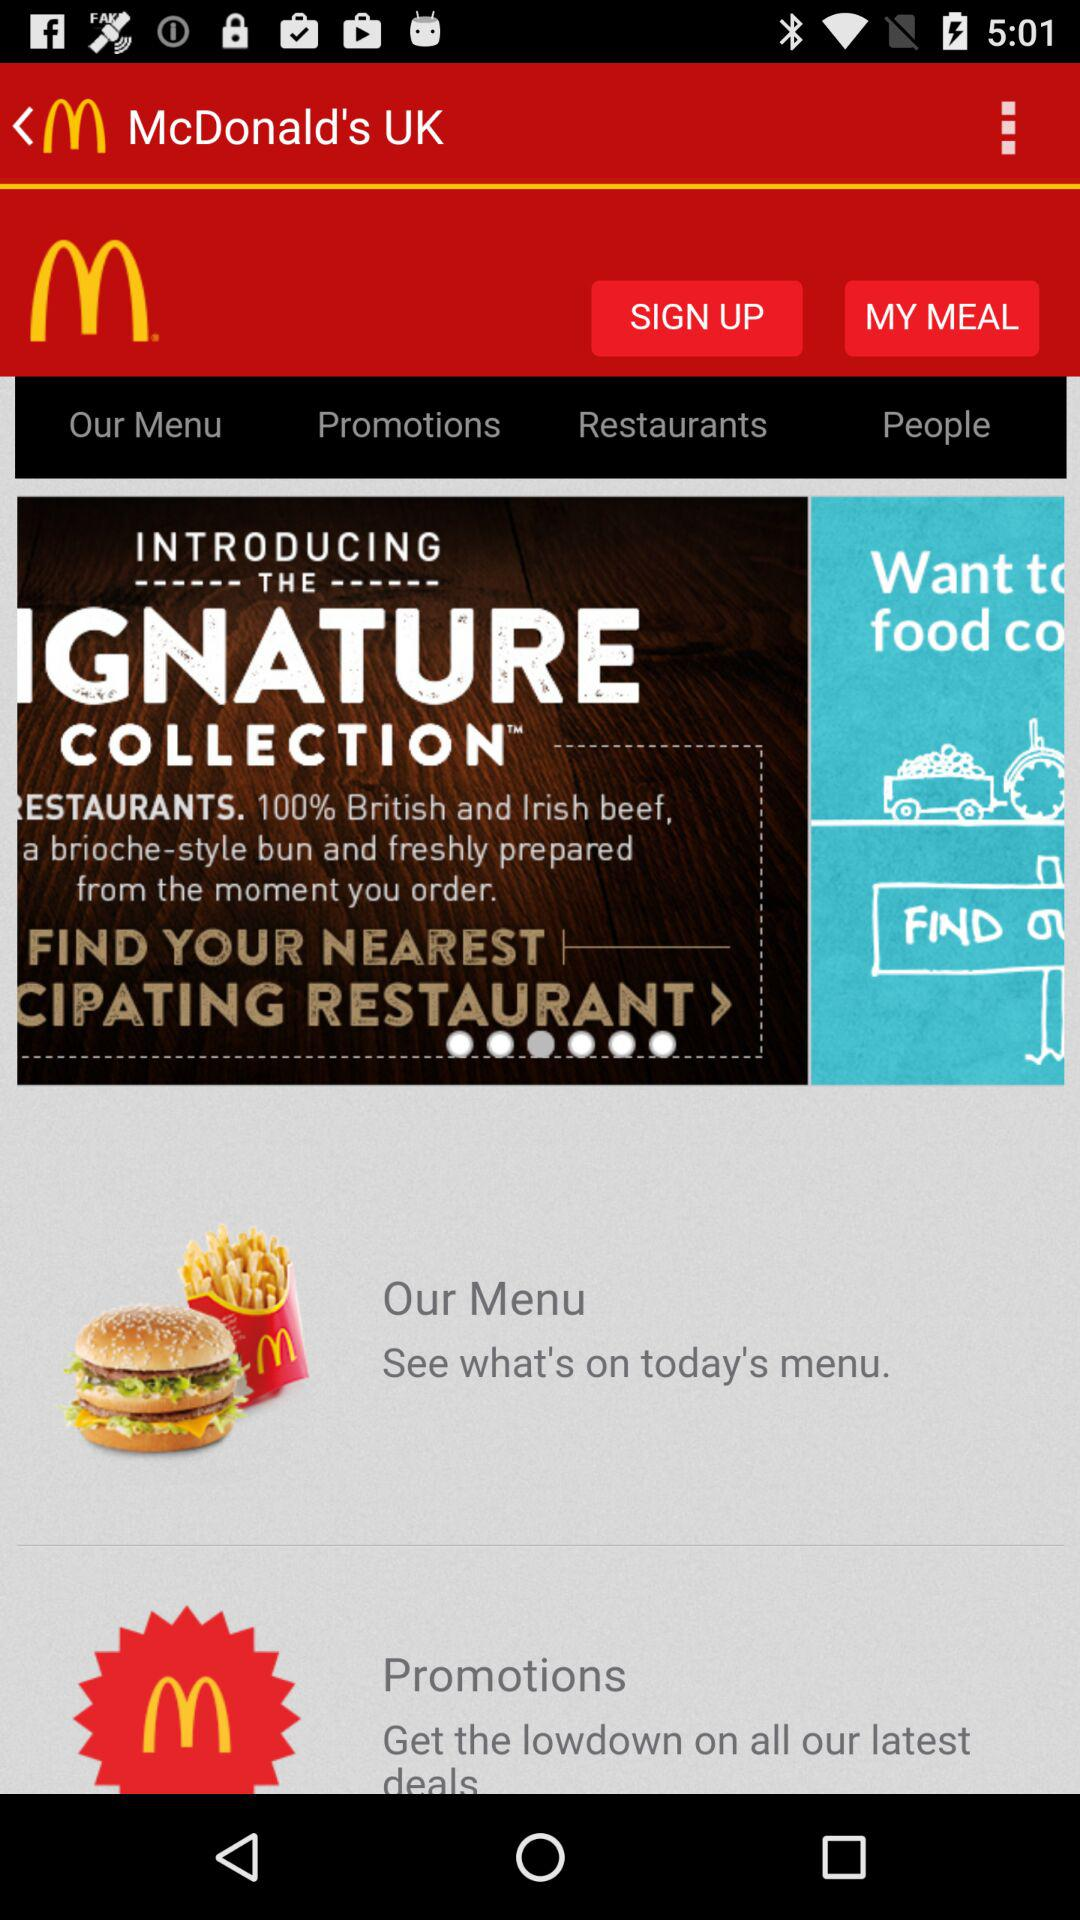Which country's beef is served? The served beef is British and Irish. 